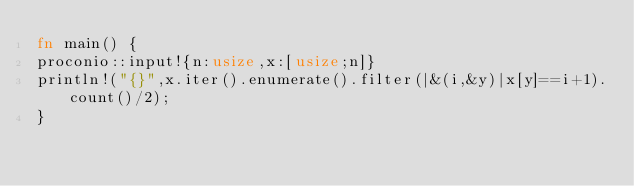Convert code to text. <code><loc_0><loc_0><loc_500><loc_500><_Rust_>fn main() {
proconio::input!{n:usize,x:[usize;n]}
println!("{}",x.iter().enumerate().filter(|&(i,&y)|x[y]==i+1).count()/2);
}</code> 